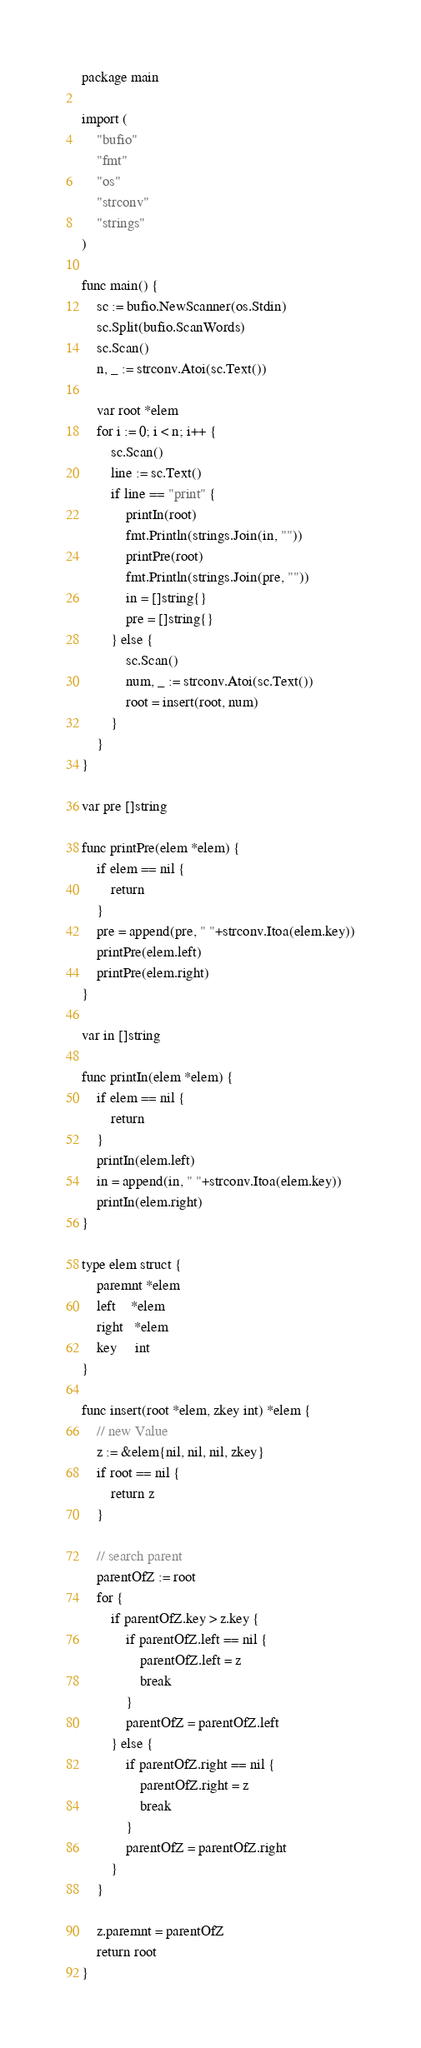Convert code to text. <code><loc_0><loc_0><loc_500><loc_500><_Go_>package main

import (
	"bufio"
	"fmt"
	"os"
	"strconv"
	"strings"
)

func main() {
	sc := bufio.NewScanner(os.Stdin)
	sc.Split(bufio.ScanWords)
	sc.Scan()
	n, _ := strconv.Atoi(sc.Text())

	var root *elem
	for i := 0; i < n; i++ {
		sc.Scan()
		line := sc.Text()
		if line == "print" {
			printIn(root)
			fmt.Println(strings.Join(in, ""))
			printPre(root)
			fmt.Println(strings.Join(pre, ""))
			in = []string{}
			pre = []string{}
		} else {
			sc.Scan()
			num, _ := strconv.Atoi(sc.Text())
			root = insert(root, num)
		}
	}
}

var pre []string

func printPre(elem *elem) {
	if elem == nil {
		return
	}
	pre = append(pre, " "+strconv.Itoa(elem.key))
	printPre(elem.left)
	printPre(elem.right)
}

var in []string

func printIn(elem *elem) {
	if elem == nil {
		return
	}
	printIn(elem.left)
	in = append(in, " "+strconv.Itoa(elem.key))
	printIn(elem.right)
}

type elem struct {
	paremnt *elem
	left    *elem
	right   *elem
	key     int
}

func insert(root *elem, zkey int) *elem {
	// new Value
	z := &elem{nil, nil, nil, zkey}
	if root == nil {
		return z
	}

	// search parent
	parentOfZ := root
	for {
		if parentOfZ.key > z.key {
			if parentOfZ.left == nil {
				parentOfZ.left = z
				break
			}
			parentOfZ = parentOfZ.left
		} else {
			if parentOfZ.right == nil {
				parentOfZ.right = z
				break
			}
			parentOfZ = parentOfZ.right
		}
	}

	z.paremnt = parentOfZ
	return root
}

</code> 